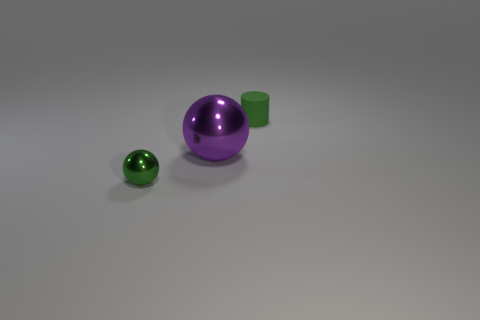Can you guess the scale or size of these objects relative to everyday items? While the exact scale is difficult to determine without a reference object, the small sphere could be likened to a standard marble, the cylinder might compare to the height of a stack of few coins, and the large sphere could be as big as an apple or a baseball. 